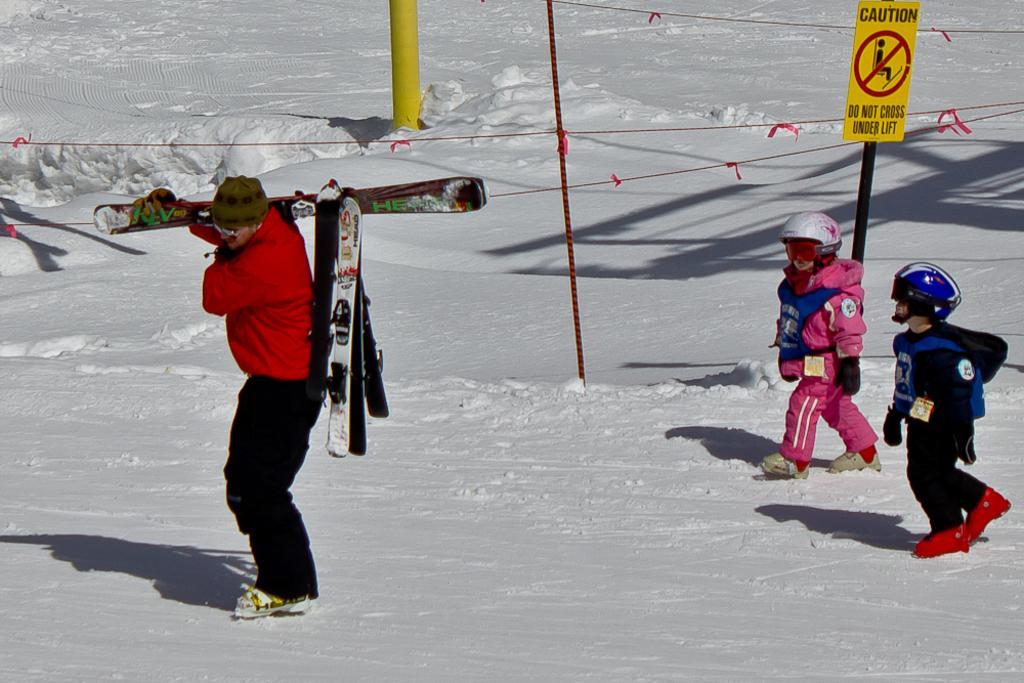In one or two sentences, can you explain what this image depicts? In this image we can see a man standing and holding skiboards. On the right there are people wearing jackets and helmets. At the bottom there is snow. In the background there is a board and a pole. We can see ropes. 